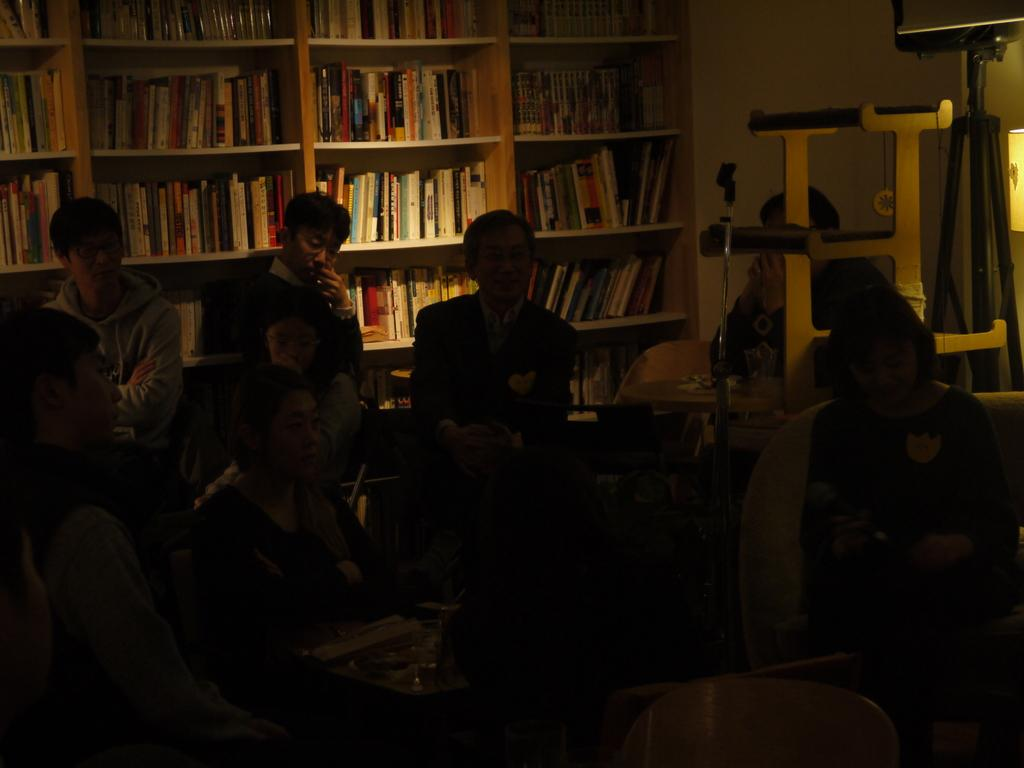What is the main subject of the image? The main subject of the image is a group of people. Where are the people located in the image? The group of people is in a library. What type of ants can be seen crawling on the roof in the image? There are no ants or roof present in the image; it features a group of people in a library. 